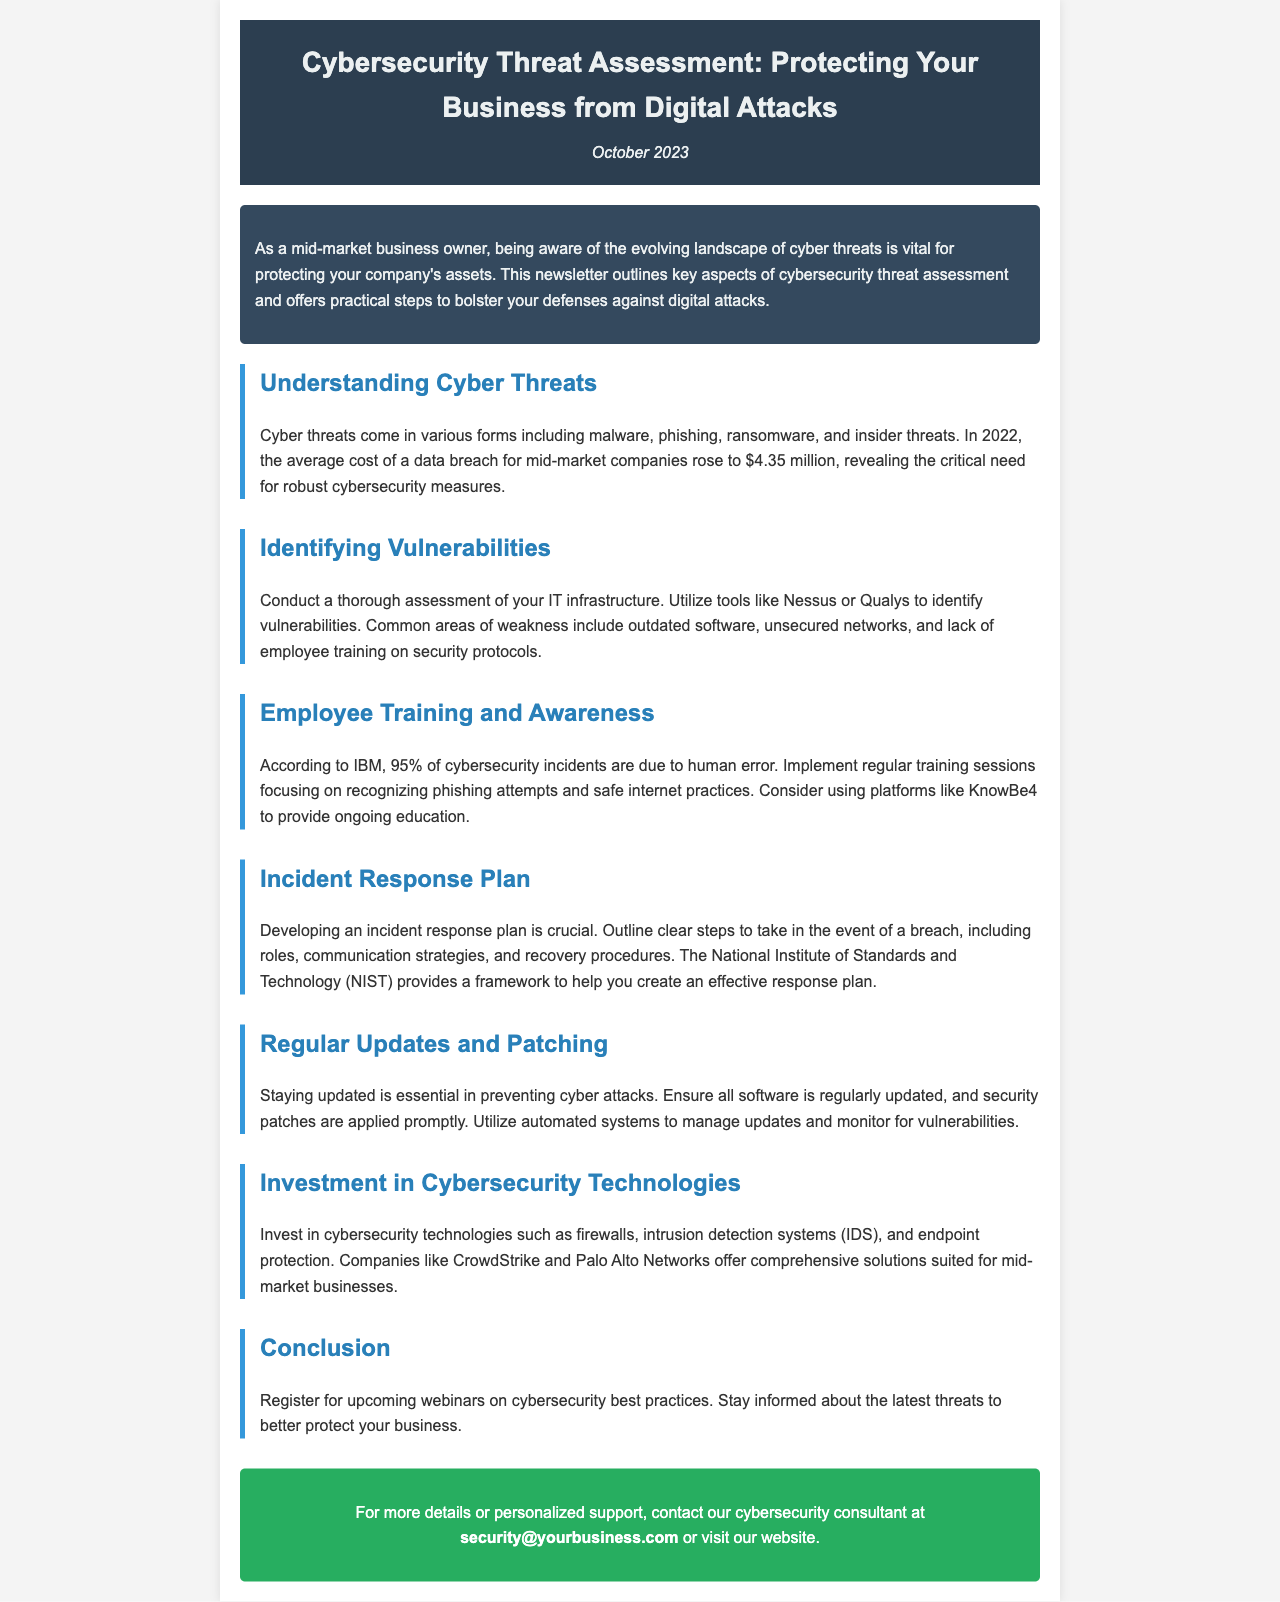what was the average cost of a data breach in 2022? The document states that the average cost of a data breach for mid-market companies in 2022 is $4.35 million.
Answer: $4.35 million which tool can be used to identify vulnerabilities? The document mentions tools like Nessus or Qualys for identifying vulnerabilities.
Answer: Nessus or Qualys what percentage of cybersecurity incidents are due to human error? According to IBM, 95% of cybersecurity incidents are attributed to human error.
Answer: 95% what framework can help create an incident response plan? The National Institute of Standards and Technology (NIST) provides a framework to help in creating an incident response plan.
Answer: NIST what is one type of cybersecurity technology recommended for mid-market businesses? The document suggests investing in technologies such as firewalls, intrusion detection systems (IDS), and endpoint protection.
Answer: firewalls how often should software updates and security patches be applied? The document emphasizes that software should be regularly updated, with security patches applied promptly.
Answer: regularly what kind of training should employees receive? Employees should receive training focusing on recognizing phishing attempts and safe internet practices.
Answer: phishing attempts and safe internet practices what is the purpose of the conclusion section? The conclusion encourages registration for upcoming webinars on cybersecurity best practices and staying informed about threats.
Answer: register for upcoming webinars 